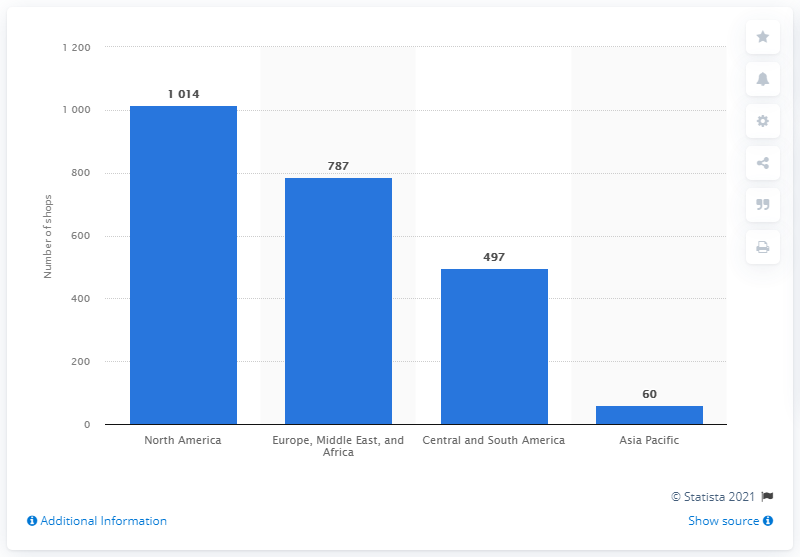Draw attention to some important aspects in this diagram. In 2020, Dufry had a total of 787 shops in Europe, the Middle East, and Africa. Dufry had 60 shops in Asia Pacific in 2020. 